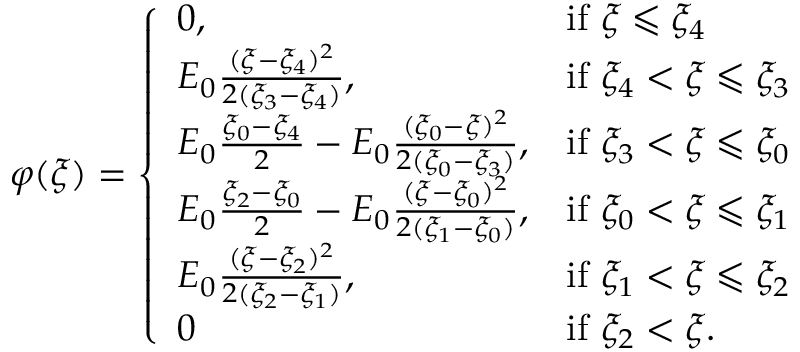Convert formula to latex. <formula><loc_0><loc_0><loc_500><loc_500>\begin{array} { r } { \varphi ( \xi ) = \left \{ \begin{array} { l l } { 0 , } & { i f \xi \leqslant \xi _ { 4 } } \\ { E _ { 0 } \frac { ( \xi - \xi _ { 4 } ) ^ { 2 } } { 2 ( \xi _ { 3 } - \xi _ { 4 } ) } , } & { i f \xi _ { 4 } < \xi \leqslant \xi _ { 3 } } \\ { E _ { 0 } \frac { \xi _ { 0 } - \xi _ { 4 } } { 2 } - E _ { 0 } \frac { ( \xi _ { 0 } - \xi ) ^ { 2 } } { 2 ( \xi _ { 0 } - \xi _ { 3 } ) } , } & { i f \xi _ { 3 } < \xi \leqslant \xi _ { 0 } } \\ { E _ { 0 } \frac { \xi _ { 2 } - \xi _ { 0 } } { 2 } - E _ { 0 } \frac { ( \xi - \xi _ { 0 } ) ^ { 2 } } { 2 ( \xi _ { 1 } - \xi _ { 0 } ) } , } & { i f \xi _ { 0 } < \xi \leqslant \xi _ { 1 } } \\ { E _ { 0 } \frac { ( \xi - \xi _ { 2 } ) ^ { 2 } } { 2 ( \xi _ { 2 } - \xi _ { 1 } ) } , } & { i f \xi _ { 1 } < \xi \leqslant \xi _ { 2 } } \\ { 0 } & { i f \xi _ { 2 } < \xi . } \end{array} } \end{array}</formula> 